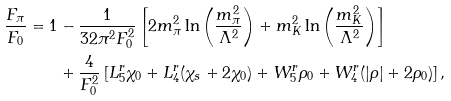<formula> <loc_0><loc_0><loc_500><loc_500>\frac { F _ { \pi } } { F _ { 0 } } = 1 & - \frac { 1 } { 3 2 \pi ^ { 2 } F _ { 0 } ^ { 2 } } \left [ 2 m _ { \pi } ^ { 2 } \ln \left ( \frac { m _ { \pi } ^ { 2 } } { \Lambda ^ { 2 } } \right ) + m _ { K } ^ { 2 } \ln \left ( \frac { m _ { K } ^ { 2 } } { \Lambda ^ { 2 } } \right ) \right ] \\ & + \frac { 4 } { F _ { 0 } ^ { 2 } } \left [ L ^ { r } _ { 5 } \chi _ { 0 } + L ^ { r } _ { 4 } ( \chi _ { s } + 2 \chi _ { 0 } ) + W _ { 5 } ^ { r } \rho _ { 0 } + W _ { 4 } ^ { r } ( | \rho | + 2 \rho _ { 0 } ) \right ] ,</formula> 